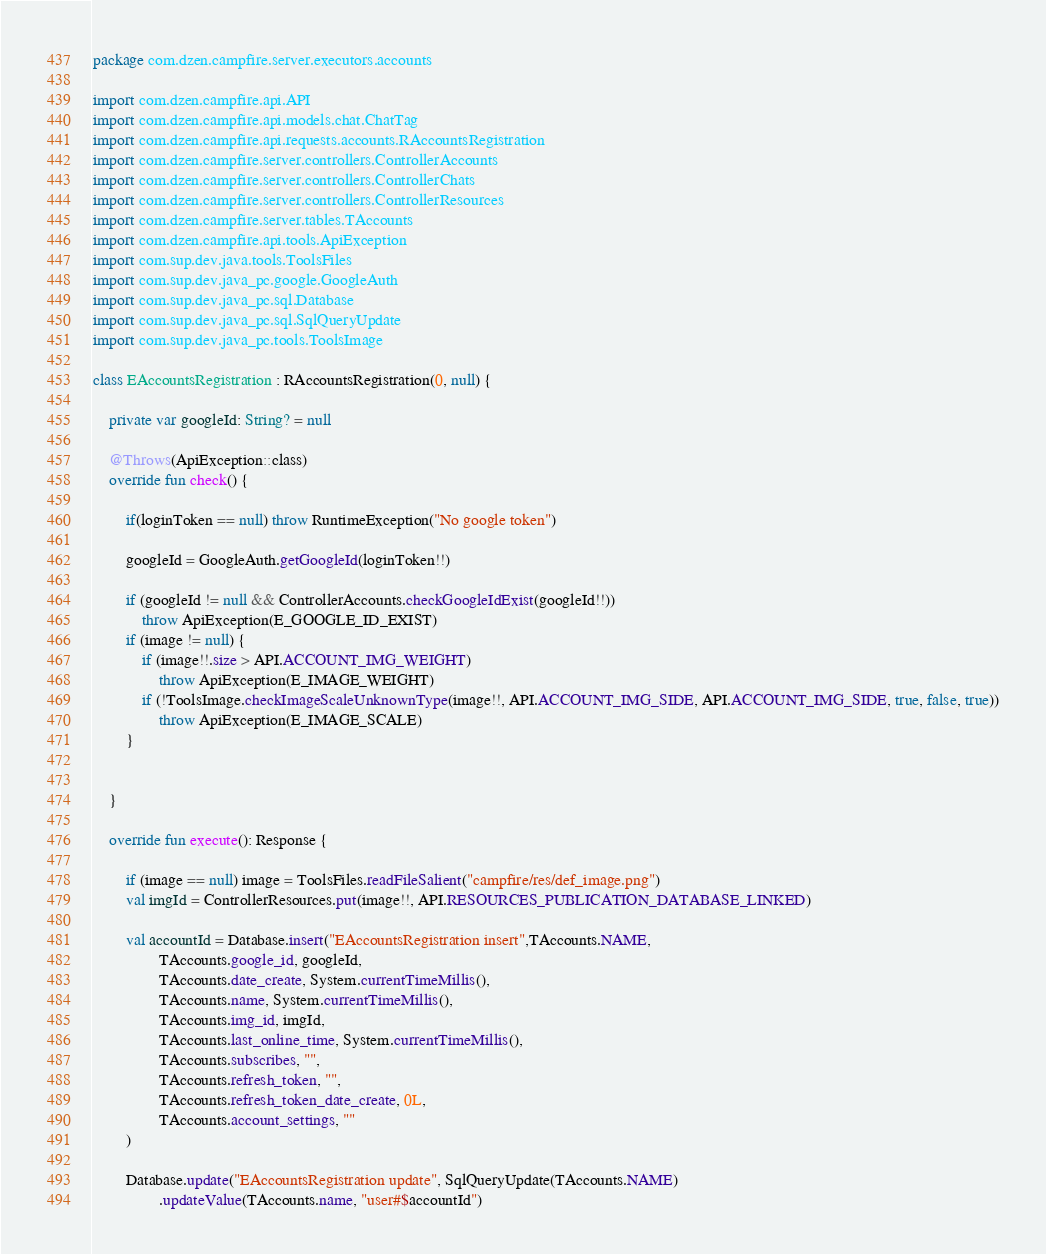Convert code to text. <code><loc_0><loc_0><loc_500><loc_500><_Kotlin_>package com.dzen.campfire.server.executors.accounts

import com.dzen.campfire.api.API
import com.dzen.campfire.api.models.chat.ChatTag
import com.dzen.campfire.api.requests.accounts.RAccountsRegistration
import com.dzen.campfire.server.controllers.ControllerAccounts
import com.dzen.campfire.server.controllers.ControllerChats
import com.dzen.campfire.server.controllers.ControllerResources
import com.dzen.campfire.server.tables.TAccounts
import com.dzen.campfire.api.tools.ApiException
import com.sup.dev.java.tools.ToolsFiles
import com.sup.dev.java_pc.google.GoogleAuth
import com.sup.dev.java_pc.sql.Database
import com.sup.dev.java_pc.sql.SqlQueryUpdate
import com.sup.dev.java_pc.tools.ToolsImage

class EAccountsRegistration : RAccountsRegistration(0, null) {

    private var googleId: String? = null

    @Throws(ApiException::class)
    override fun check() {

        if(loginToken == null) throw RuntimeException("No google token")

        googleId = GoogleAuth.getGoogleId(loginToken!!)

        if (googleId != null && ControllerAccounts.checkGoogleIdExist(googleId!!))
            throw ApiException(E_GOOGLE_ID_EXIST)
        if (image != null) {
            if (image!!.size > API.ACCOUNT_IMG_WEIGHT)
                throw ApiException(E_IMAGE_WEIGHT)
            if (!ToolsImage.checkImageScaleUnknownType(image!!, API.ACCOUNT_IMG_SIDE, API.ACCOUNT_IMG_SIDE, true, false, true))
                throw ApiException(E_IMAGE_SCALE)
        }


    }

    override fun execute(): Response {

        if (image == null) image = ToolsFiles.readFileSalient("campfire/res/def_image.png")
        val imgId = ControllerResources.put(image!!, API.RESOURCES_PUBLICATION_DATABASE_LINKED)

        val accountId = Database.insert("EAccountsRegistration insert",TAccounts.NAME,
                TAccounts.google_id, googleId,
                TAccounts.date_create, System.currentTimeMillis(),
                TAccounts.name, System.currentTimeMillis(),
                TAccounts.img_id, imgId,
                TAccounts.last_online_time, System.currentTimeMillis(),
                TAccounts.subscribes, "",
                TAccounts.refresh_token, "",
                TAccounts.refresh_token_date_create, 0L,
                TAccounts.account_settings, ""
        )

        Database.update("EAccountsRegistration update", SqlQueryUpdate(TAccounts.NAME)
                .updateValue(TAccounts.name, "user#$accountId")</code> 